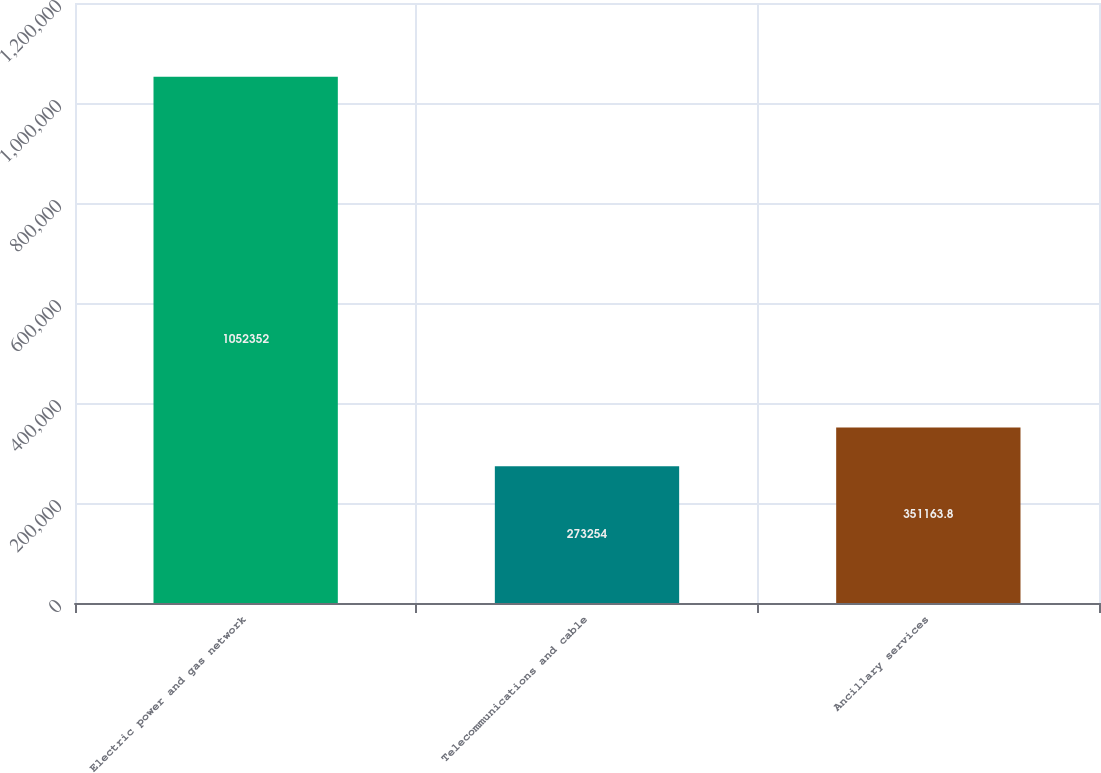<chart> <loc_0><loc_0><loc_500><loc_500><bar_chart><fcel>Electric power and gas network<fcel>Telecommunications and cable<fcel>Ancillary services<nl><fcel>1.05235e+06<fcel>273254<fcel>351164<nl></chart> 